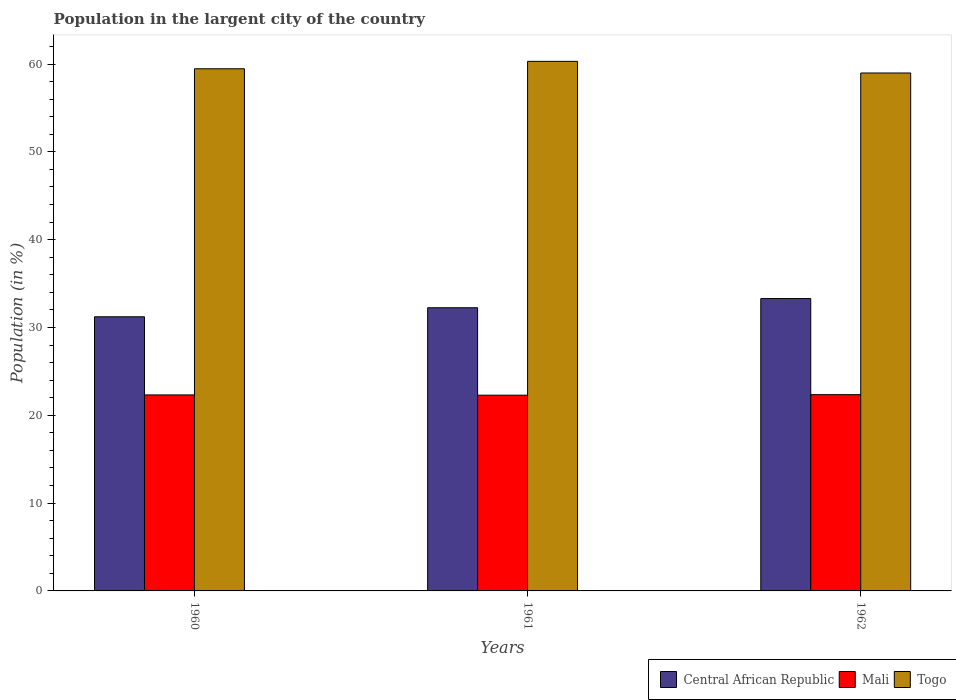Are the number of bars on each tick of the X-axis equal?
Offer a very short reply. Yes. How many bars are there on the 2nd tick from the left?
Your answer should be very brief. 3. In how many cases, is the number of bars for a given year not equal to the number of legend labels?
Provide a short and direct response. 0. What is the percentage of population in the largent city in Mali in 1962?
Your answer should be very brief. 22.35. Across all years, what is the maximum percentage of population in the largent city in Central African Republic?
Keep it short and to the point. 33.29. Across all years, what is the minimum percentage of population in the largent city in Central African Republic?
Make the answer very short. 31.22. In which year was the percentage of population in the largent city in Mali maximum?
Provide a succinct answer. 1962. In which year was the percentage of population in the largent city in Mali minimum?
Give a very brief answer. 1961. What is the total percentage of population in the largent city in Central African Republic in the graph?
Offer a terse response. 96.76. What is the difference between the percentage of population in the largent city in Central African Republic in 1960 and that in 1962?
Give a very brief answer. -2.07. What is the difference between the percentage of population in the largent city in Togo in 1962 and the percentage of population in the largent city in Central African Republic in 1961?
Provide a short and direct response. 26.73. What is the average percentage of population in the largent city in Togo per year?
Your answer should be compact. 59.58. In the year 1962, what is the difference between the percentage of population in the largent city in Togo and percentage of population in the largent city in Central African Republic?
Your response must be concise. 25.69. In how many years, is the percentage of population in the largent city in Central African Republic greater than 24 %?
Offer a very short reply. 3. What is the ratio of the percentage of population in the largent city in Togo in 1960 to that in 1962?
Provide a short and direct response. 1.01. What is the difference between the highest and the second highest percentage of population in the largent city in Togo?
Offer a terse response. 0.84. What is the difference between the highest and the lowest percentage of population in the largent city in Central African Republic?
Make the answer very short. 2.07. What does the 1st bar from the left in 1961 represents?
Keep it short and to the point. Central African Republic. What does the 2nd bar from the right in 1961 represents?
Offer a very short reply. Mali. Are the values on the major ticks of Y-axis written in scientific E-notation?
Your response must be concise. No. Does the graph contain any zero values?
Your answer should be compact. No. How are the legend labels stacked?
Offer a very short reply. Horizontal. What is the title of the graph?
Make the answer very short. Population in the largent city of the country. What is the label or title of the X-axis?
Offer a very short reply. Years. What is the Population (in %) of Central African Republic in 1960?
Provide a short and direct response. 31.22. What is the Population (in %) of Mali in 1960?
Offer a terse response. 22.32. What is the Population (in %) in Togo in 1960?
Your response must be concise. 59.46. What is the Population (in %) in Central African Republic in 1961?
Keep it short and to the point. 32.25. What is the Population (in %) of Mali in 1961?
Provide a succinct answer. 22.29. What is the Population (in %) in Togo in 1961?
Provide a short and direct response. 60.31. What is the Population (in %) of Central African Republic in 1962?
Offer a very short reply. 33.29. What is the Population (in %) in Mali in 1962?
Your answer should be compact. 22.35. What is the Population (in %) of Togo in 1962?
Provide a short and direct response. 58.98. Across all years, what is the maximum Population (in %) of Central African Republic?
Ensure brevity in your answer.  33.29. Across all years, what is the maximum Population (in %) of Mali?
Make the answer very short. 22.35. Across all years, what is the maximum Population (in %) in Togo?
Make the answer very short. 60.31. Across all years, what is the minimum Population (in %) of Central African Republic?
Offer a very short reply. 31.22. Across all years, what is the minimum Population (in %) in Mali?
Provide a succinct answer. 22.29. Across all years, what is the minimum Population (in %) in Togo?
Provide a short and direct response. 58.98. What is the total Population (in %) in Central African Republic in the graph?
Give a very brief answer. 96.76. What is the total Population (in %) of Mali in the graph?
Provide a succinct answer. 66.96. What is the total Population (in %) of Togo in the graph?
Make the answer very short. 178.75. What is the difference between the Population (in %) of Central African Republic in 1960 and that in 1961?
Offer a very short reply. -1.03. What is the difference between the Population (in %) in Mali in 1960 and that in 1961?
Provide a short and direct response. 0.03. What is the difference between the Population (in %) in Togo in 1960 and that in 1961?
Give a very brief answer. -0.84. What is the difference between the Population (in %) of Central African Republic in 1960 and that in 1962?
Your answer should be compact. -2.07. What is the difference between the Population (in %) of Mali in 1960 and that in 1962?
Provide a short and direct response. -0.03. What is the difference between the Population (in %) in Togo in 1960 and that in 1962?
Provide a short and direct response. 0.48. What is the difference between the Population (in %) in Central African Republic in 1961 and that in 1962?
Make the answer very short. -1.05. What is the difference between the Population (in %) of Mali in 1961 and that in 1962?
Your answer should be compact. -0.06. What is the difference between the Population (in %) in Togo in 1961 and that in 1962?
Your response must be concise. 1.32. What is the difference between the Population (in %) in Central African Republic in 1960 and the Population (in %) in Mali in 1961?
Your response must be concise. 8.93. What is the difference between the Population (in %) of Central African Republic in 1960 and the Population (in %) of Togo in 1961?
Your answer should be compact. -29.09. What is the difference between the Population (in %) of Mali in 1960 and the Population (in %) of Togo in 1961?
Offer a terse response. -37.99. What is the difference between the Population (in %) in Central African Republic in 1960 and the Population (in %) in Mali in 1962?
Ensure brevity in your answer.  8.87. What is the difference between the Population (in %) of Central African Republic in 1960 and the Population (in %) of Togo in 1962?
Your answer should be very brief. -27.76. What is the difference between the Population (in %) in Mali in 1960 and the Population (in %) in Togo in 1962?
Offer a very short reply. -36.66. What is the difference between the Population (in %) of Central African Republic in 1961 and the Population (in %) of Mali in 1962?
Provide a short and direct response. 9.9. What is the difference between the Population (in %) of Central African Republic in 1961 and the Population (in %) of Togo in 1962?
Make the answer very short. -26.73. What is the difference between the Population (in %) of Mali in 1961 and the Population (in %) of Togo in 1962?
Provide a succinct answer. -36.69. What is the average Population (in %) in Central African Republic per year?
Your answer should be very brief. 32.25. What is the average Population (in %) of Mali per year?
Offer a very short reply. 22.32. What is the average Population (in %) of Togo per year?
Keep it short and to the point. 59.58. In the year 1960, what is the difference between the Population (in %) in Central African Republic and Population (in %) in Mali?
Provide a succinct answer. 8.9. In the year 1960, what is the difference between the Population (in %) in Central African Republic and Population (in %) in Togo?
Keep it short and to the point. -28.24. In the year 1960, what is the difference between the Population (in %) in Mali and Population (in %) in Togo?
Ensure brevity in your answer.  -37.14. In the year 1961, what is the difference between the Population (in %) in Central African Republic and Population (in %) in Mali?
Offer a very short reply. 9.96. In the year 1961, what is the difference between the Population (in %) in Central African Republic and Population (in %) in Togo?
Provide a succinct answer. -28.06. In the year 1961, what is the difference between the Population (in %) of Mali and Population (in %) of Togo?
Offer a terse response. -38.02. In the year 1962, what is the difference between the Population (in %) of Central African Republic and Population (in %) of Mali?
Make the answer very short. 10.94. In the year 1962, what is the difference between the Population (in %) of Central African Republic and Population (in %) of Togo?
Ensure brevity in your answer.  -25.69. In the year 1962, what is the difference between the Population (in %) in Mali and Population (in %) in Togo?
Offer a terse response. -36.63. What is the ratio of the Population (in %) in Central African Republic in 1960 to that in 1961?
Offer a terse response. 0.97. What is the ratio of the Population (in %) of Central African Republic in 1960 to that in 1962?
Provide a succinct answer. 0.94. What is the ratio of the Population (in %) in Mali in 1960 to that in 1962?
Provide a succinct answer. 1. What is the ratio of the Population (in %) in Togo in 1960 to that in 1962?
Provide a short and direct response. 1.01. What is the ratio of the Population (in %) in Central African Republic in 1961 to that in 1962?
Provide a succinct answer. 0.97. What is the ratio of the Population (in %) in Mali in 1961 to that in 1962?
Your answer should be compact. 1. What is the ratio of the Population (in %) of Togo in 1961 to that in 1962?
Keep it short and to the point. 1.02. What is the difference between the highest and the second highest Population (in %) of Central African Republic?
Keep it short and to the point. 1.05. What is the difference between the highest and the second highest Population (in %) of Mali?
Keep it short and to the point. 0.03. What is the difference between the highest and the second highest Population (in %) of Togo?
Make the answer very short. 0.84. What is the difference between the highest and the lowest Population (in %) in Central African Republic?
Give a very brief answer. 2.07. What is the difference between the highest and the lowest Population (in %) of Mali?
Ensure brevity in your answer.  0.06. What is the difference between the highest and the lowest Population (in %) of Togo?
Your response must be concise. 1.32. 